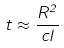Convert formula to latex. <formula><loc_0><loc_0><loc_500><loc_500>t \approx \frac { R ^ { 2 } } { c l }</formula> 